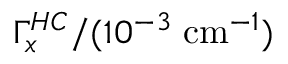Convert formula to latex. <formula><loc_0><loc_0><loc_500><loc_500>\Gamma _ { x } ^ { H C } / ( 1 0 ^ { - 3 } \, c m ^ { - 1 } )</formula> 